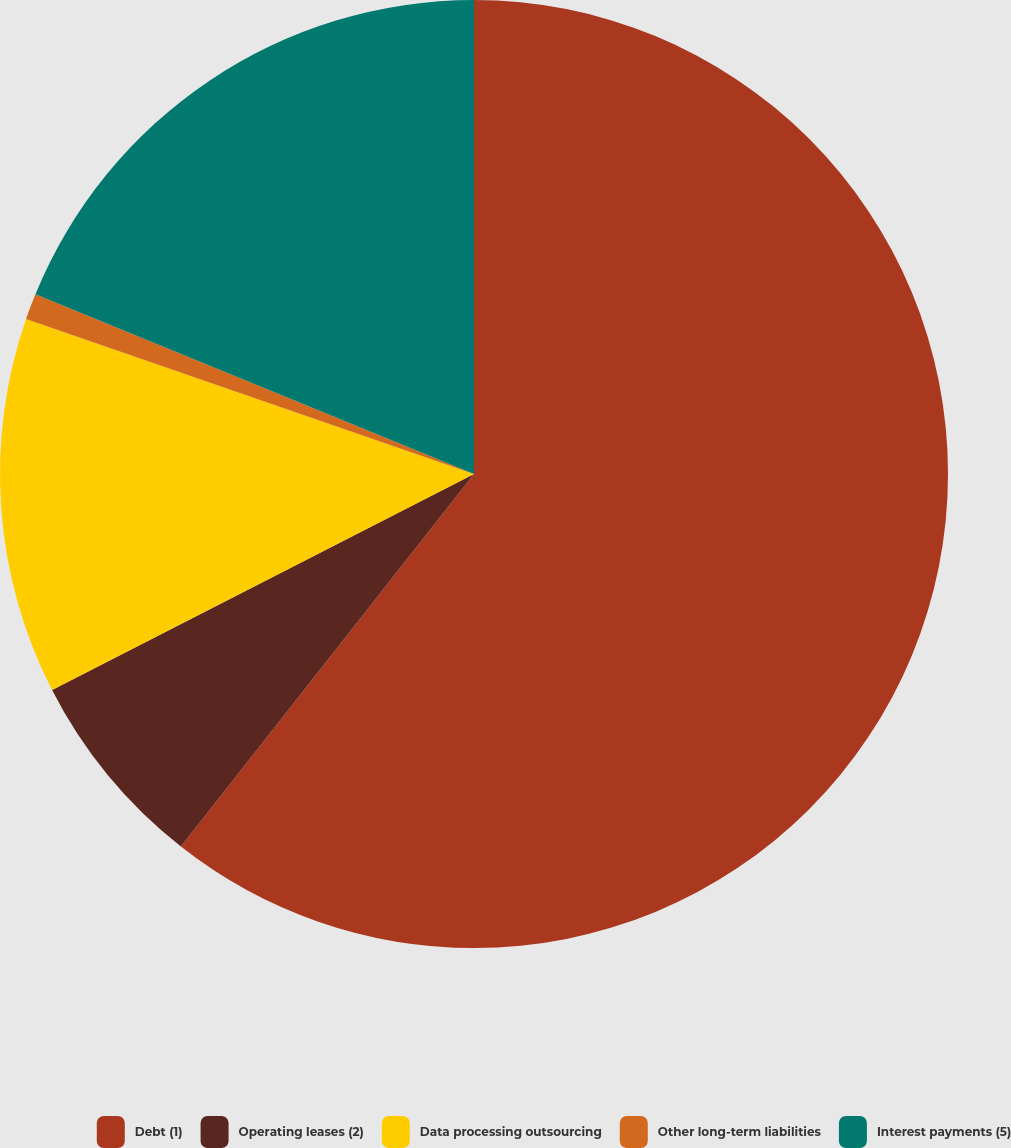Convert chart. <chart><loc_0><loc_0><loc_500><loc_500><pie_chart><fcel>Debt (1)<fcel>Operating leases (2)<fcel>Data processing outsourcing<fcel>Other long-term liabilities<fcel>Interest payments (5)<nl><fcel>60.61%<fcel>6.86%<fcel>12.83%<fcel>0.89%<fcel>18.81%<nl></chart> 